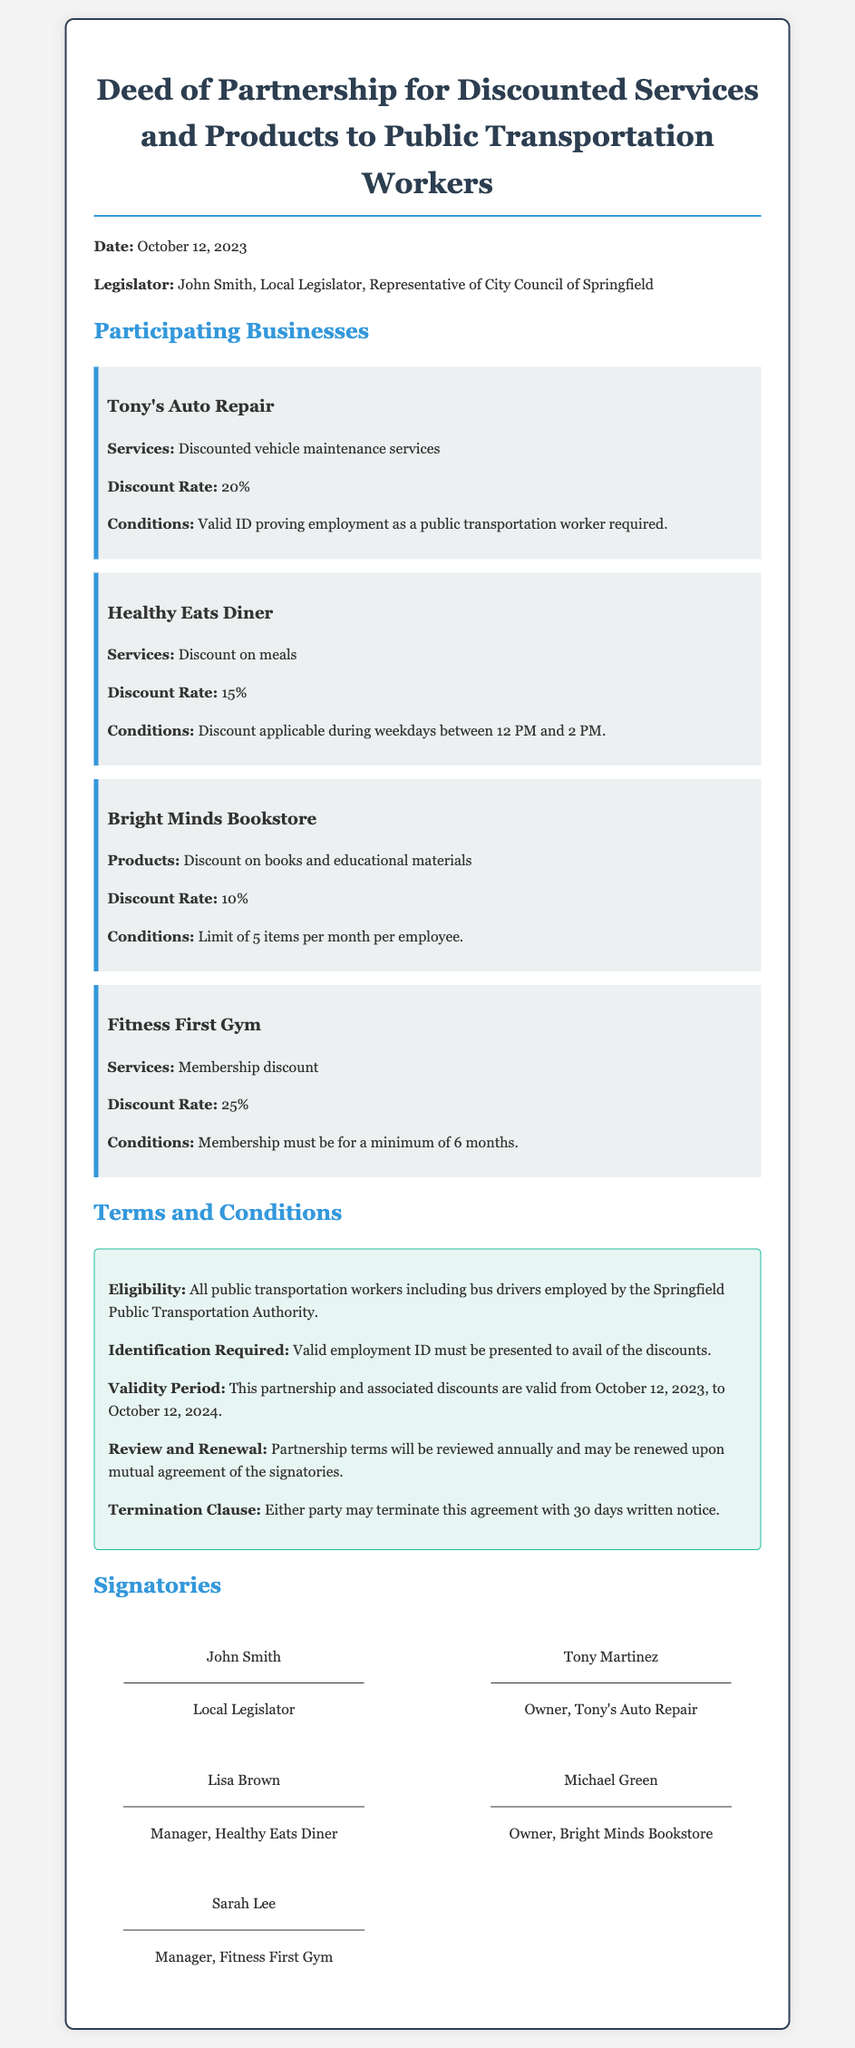What is the date of the deed? The date of the deed is mentioned at the beginning of the document.
Answer: October 12, 2023 Who is the local legislator? The local legislator's name is listed in the document along with their title.
Answer: John Smith What is the discount rate for Tony's Auto Repair? The discount rate for Tony's Auto Repair is explicitly stated in the section regarding participating businesses.
Answer: 20% What condition must be met to avail discounts at Healthy Eats Diner? The condition relates to the timing of when the discount can be utilized, as specified in the business description.
Answer: Weekdays between 12 PM and 2 PM How long is the validity period of the partnership? The validity period is noted in the terms and conditions section of the deed.
Answer: From October 12, 2023, to October 12, 2024 Which business offers the highest discount rate? This information can be determined by comparing the discount rates listed for each business in the document.
Answer: Fitness First Gym What is required to prove eligibility for discounts? The document specifies what identification must be presented to qualify for the discounts.
Answer: Valid employment ID What is the termination notice period specified in the deed? The termination clause provides a specific period required for notice before termination can take effect.
Answer: 30 days Who is the owner of Bright Minds Bookstore? The document includes signatories, which list the individual names and their titles.
Answer: Michael Green 